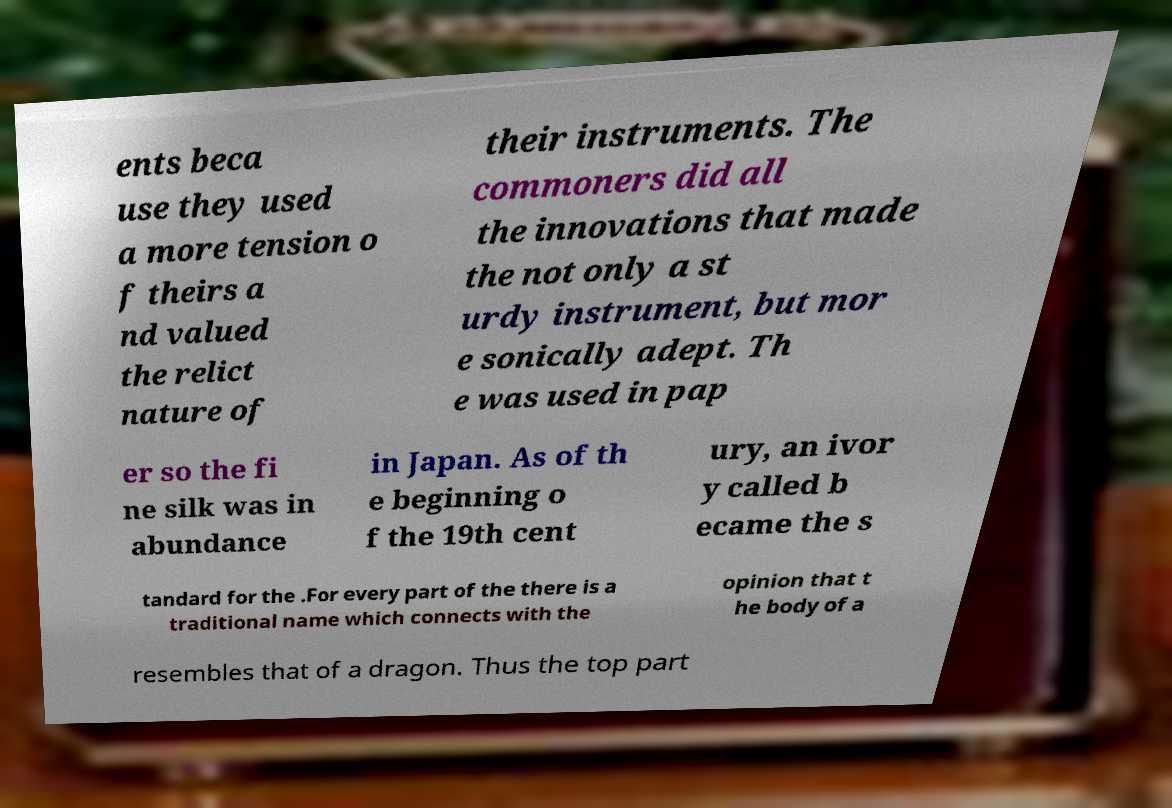Please identify and transcribe the text found in this image. ents beca use they used a more tension o f theirs a nd valued the relict nature of their instruments. The commoners did all the innovations that made the not only a st urdy instrument, but mor e sonically adept. Th e was used in pap er so the fi ne silk was in abundance in Japan. As of th e beginning o f the 19th cent ury, an ivor y called b ecame the s tandard for the .For every part of the there is a traditional name which connects with the opinion that t he body of a resembles that of a dragon. Thus the top part 